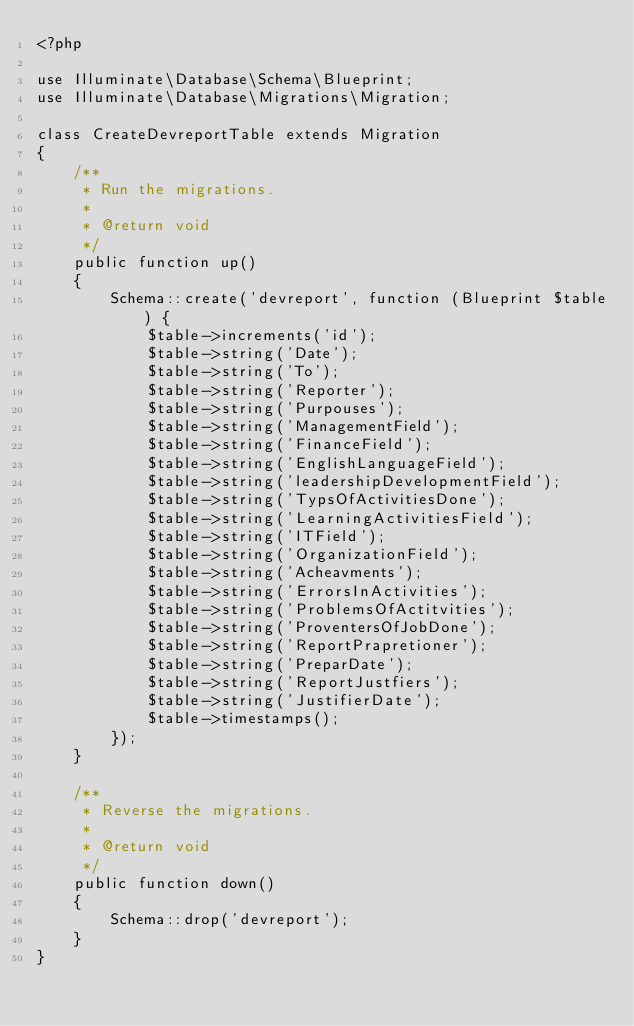Convert code to text. <code><loc_0><loc_0><loc_500><loc_500><_PHP_><?php

use Illuminate\Database\Schema\Blueprint;
use Illuminate\Database\Migrations\Migration;

class CreateDevreportTable extends Migration
{
    /**
     * Run the migrations.
     *
     * @return void
     */
    public function up()
    {
        Schema::create('devreport', function (Blueprint $table) {
            $table->increments('id');
            $table->string('Date');
            $table->string('To');
            $table->string('Reporter');
            $table->string('Purpouses');
            $table->string('ManagementField');
            $table->string('FinanceField');
            $table->string('EnglishLanguageField');
            $table->string('leadershipDevelopmentField');
            $table->string('TypsOfActivitiesDone');
            $table->string('LearningActivitiesField');
            $table->string('ITField');
            $table->string('OrganizationField');
            $table->string('Acheavments');
            $table->string('ErrorsInActivities');
            $table->string('ProblemsOfActitvities');
            $table->string('ProventersOfJobDone');
            $table->string('ReportPrapretioner');
            $table->string('PreparDate');
            $table->string('ReportJustfiers');
            $table->string('JustifierDate');
            $table->timestamps();
        });
    }

    /**
     * Reverse the migrations.
     *
     * @return void
     */
    public function down()
    {
        Schema::drop('devreport');
    }
}
</code> 